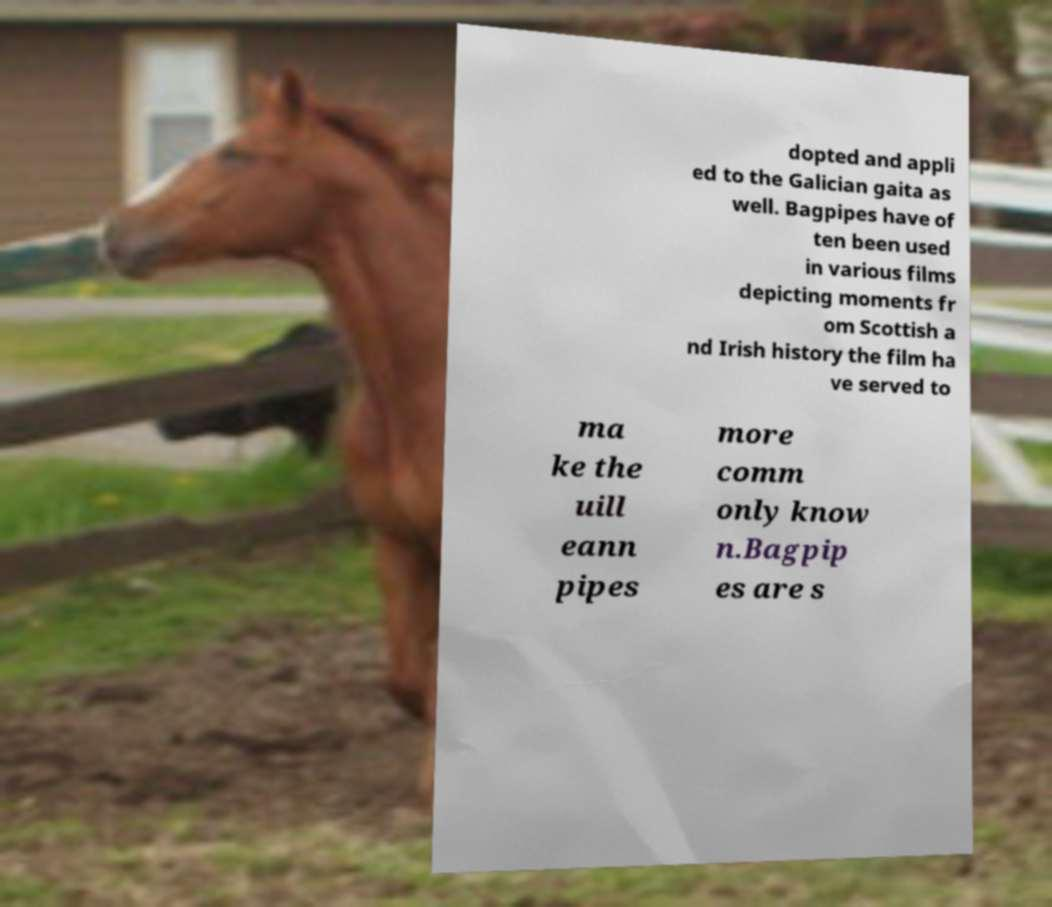There's text embedded in this image that I need extracted. Can you transcribe it verbatim? dopted and appli ed to the Galician gaita as well. Bagpipes have of ten been used in various films depicting moments fr om Scottish a nd Irish history the film ha ve served to ma ke the uill eann pipes more comm only know n.Bagpip es are s 